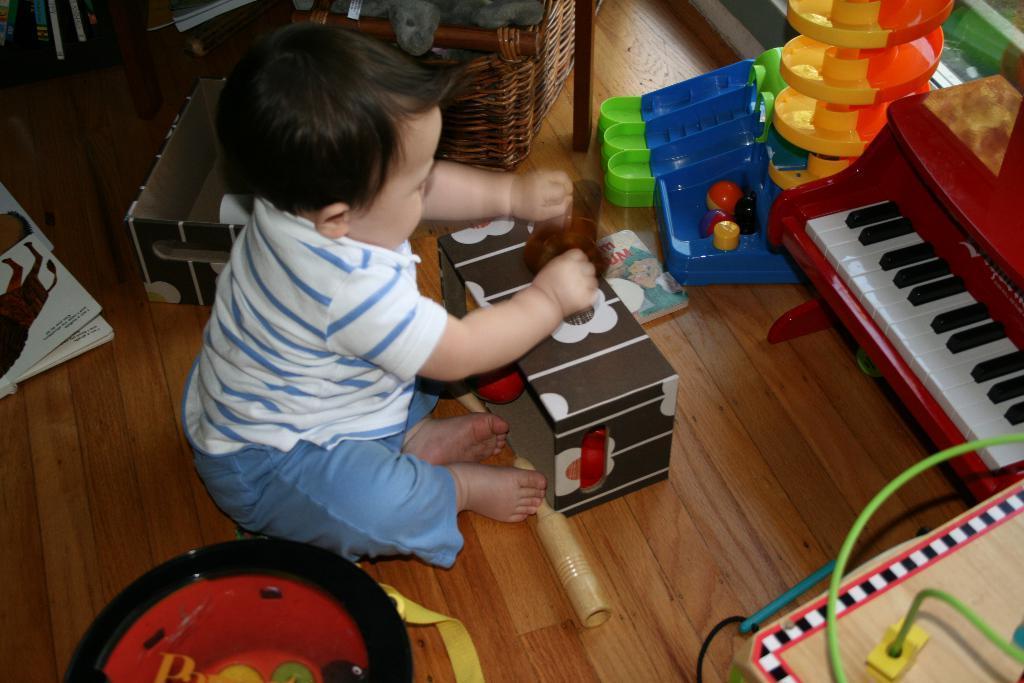Could you give a brief overview of what you see in this image? In this picture, there is a kid playing with some toys in front of him on the floor. Beside him, there is a basket with a teddy bear in it. 